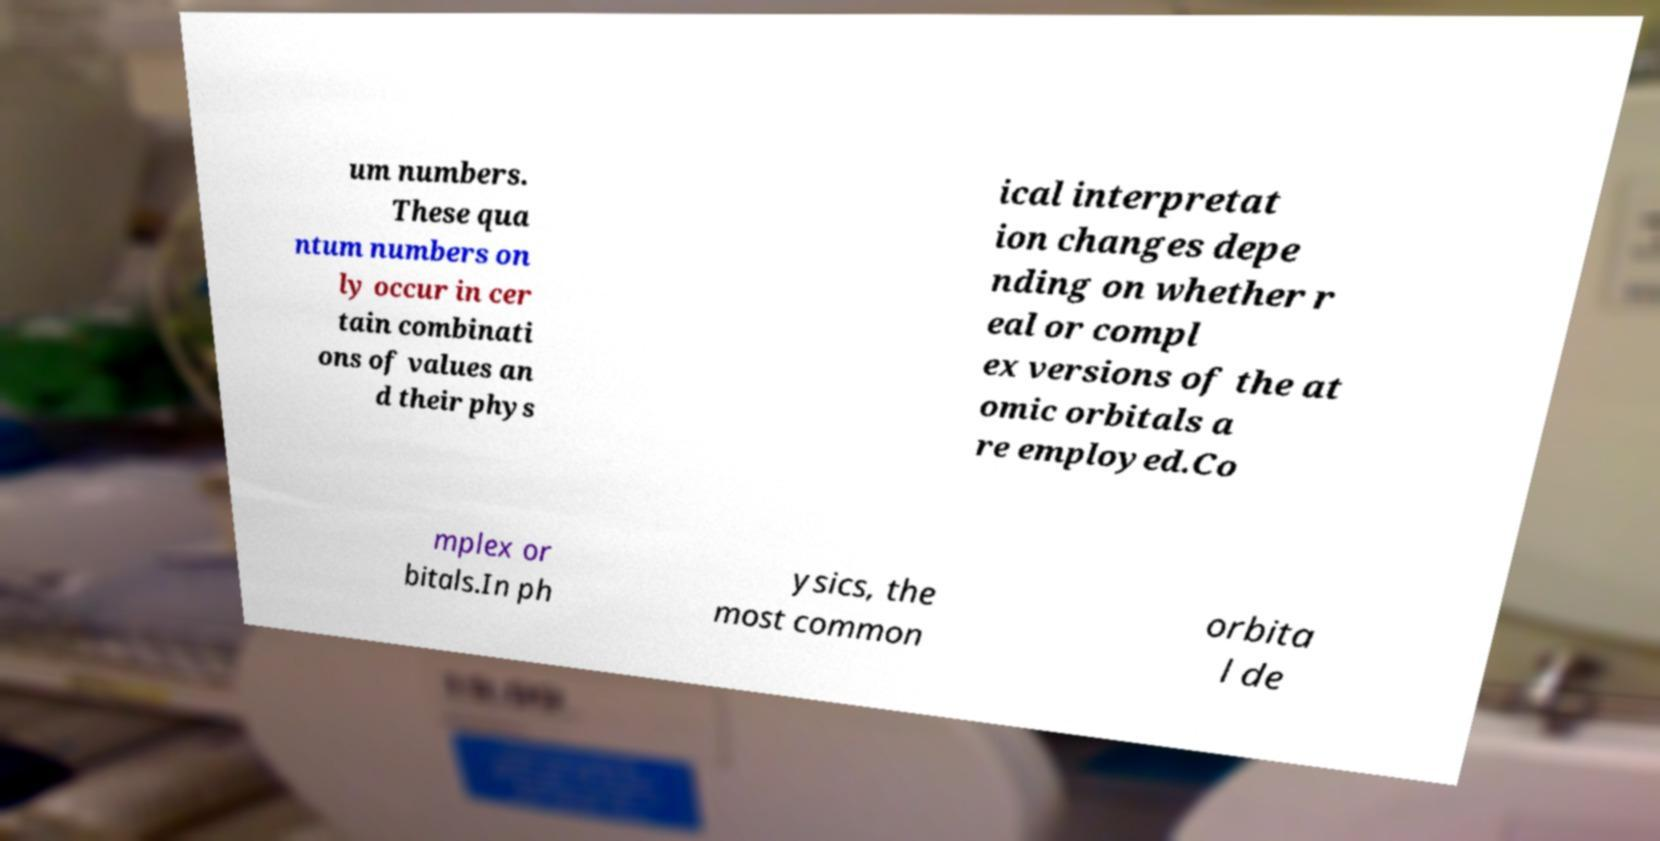What messages or text are displayed in this image? I need them in a readable, typed format. um numbers. These qua ntum numbers on ly occur in cer tain combinati ons of values an d their phys ical interpretat ion changes depe nding on whether r eal or compl ex versions of the at omic orbitals a re employed.Co mplex or bitals.In ph ysics, the most common orbita l de 